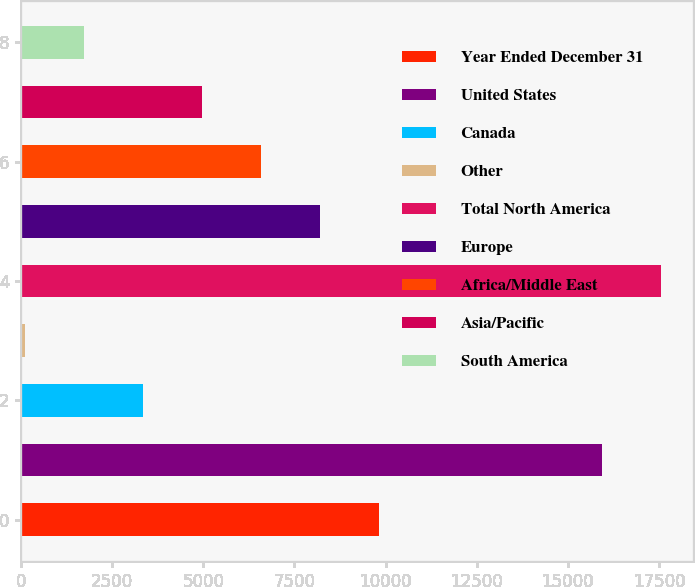<chart> <loc_0><loc_0><loc_500><loc_500><bar_chart><fcel>Year Ended December 31<fcel>United States<fcel>Canada<fcel>Other<fcel>Total North America<fcel>Europe<fcel>Africa/Middle East<fcel>Asia/Pacific<fcel>South America<nl><fcel>9821<fcel>15935<fcel>3355<fcel>122<fcel>17551.5<fcel>8204.5<fcel>6588<fcel>4971.5<fcel>1738.5<nl></chart> 